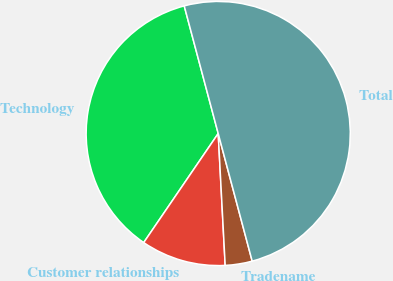Convert chart. <chart><loc_0><loc_0><loc_500><loc_500><pie_chart><fcel>Technology<fcel>Customer relationships<fcel>Tradename<fcel>Total<nl><fcel>36.32%<fcel>10.38%<fcel>3.3%<fcel>50.0%<nl></chart> 